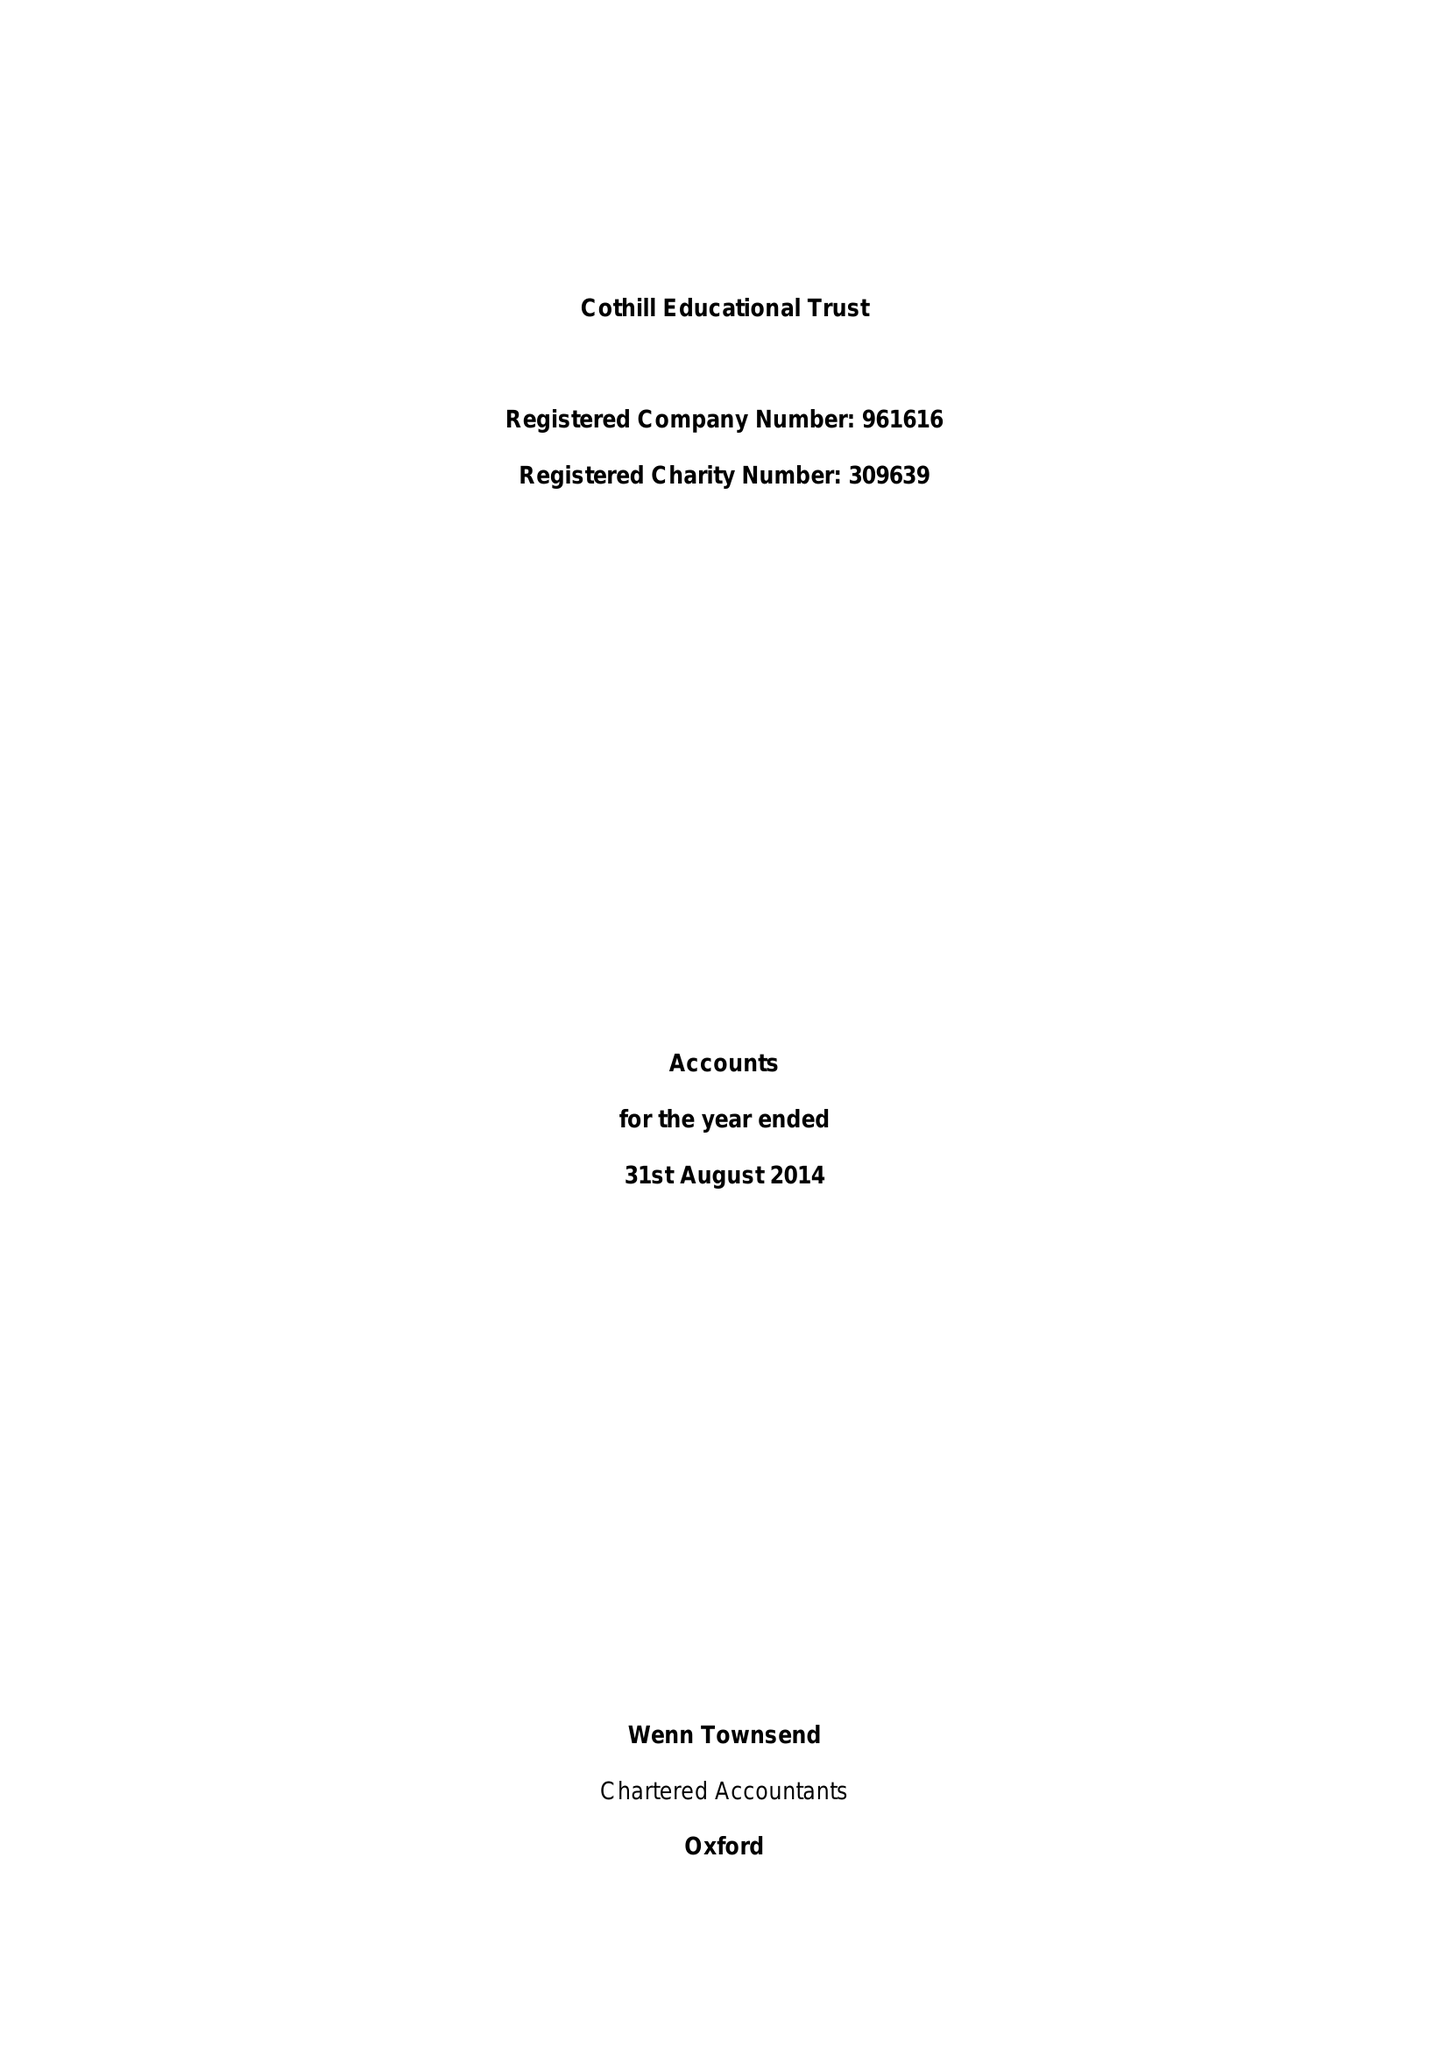What is the value for the address__post_town?
Answer the question using a single word or phrase. ABINGDON 